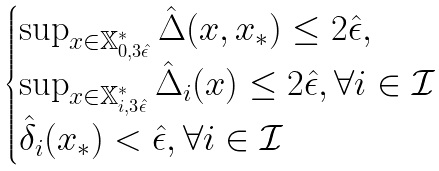<formula> <loc_0><loc_0><loc_500><loc_500>\begin{cases} \sup _ { x \in \mathbb { X } ^ { * } _ { 0 , 3 \hat { \epsilon } } } \hat { \Delta } ( x , x _ { * } ) \leq 2 \hat { \epsilon } , \\ \sup _ { x \in \mathbb { X } ^ { * } _ { i , 3 \hat { \epsilon } } } \hat { \Delta } _ { i } ( x ) \leq 2 \hat { \epsilon } , \forall i \in \mathcal { I } \\ \hat { \delta } _ { i } ( x _ { * } ) < \hat { \epsilon } , \forall i \in \mathcal { I } \end{cases}</formula> 